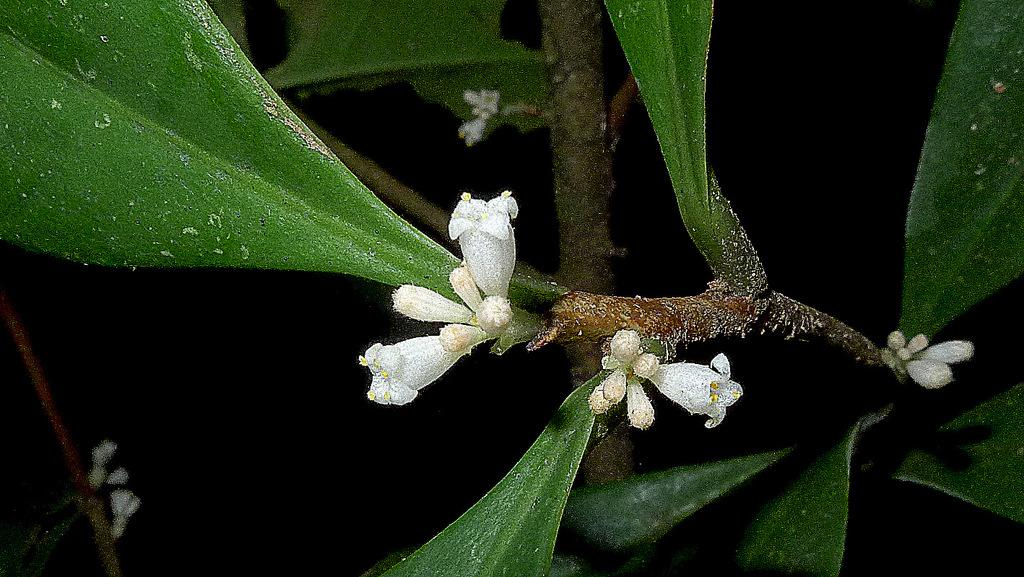What is present in the picture? There is a plant in the picture. What features does the plant have? The plant has leaves and small flowers on its stem. What color are the flowers on the plant? The flowers are white in color. How many bikes are parked next to the plant in the image? There are no bikes present in the image; it only features a plant with white flowers. 